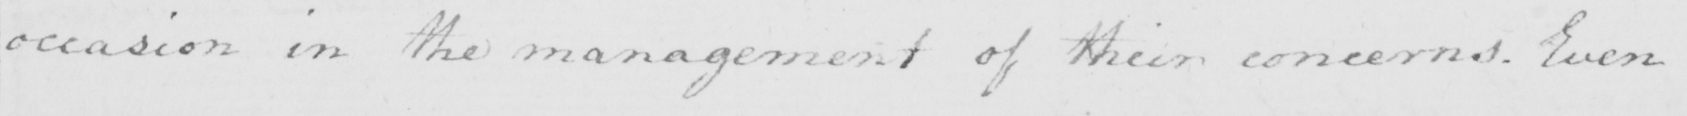What does this handwritten line say? occasion in the management of their concerns . Even 